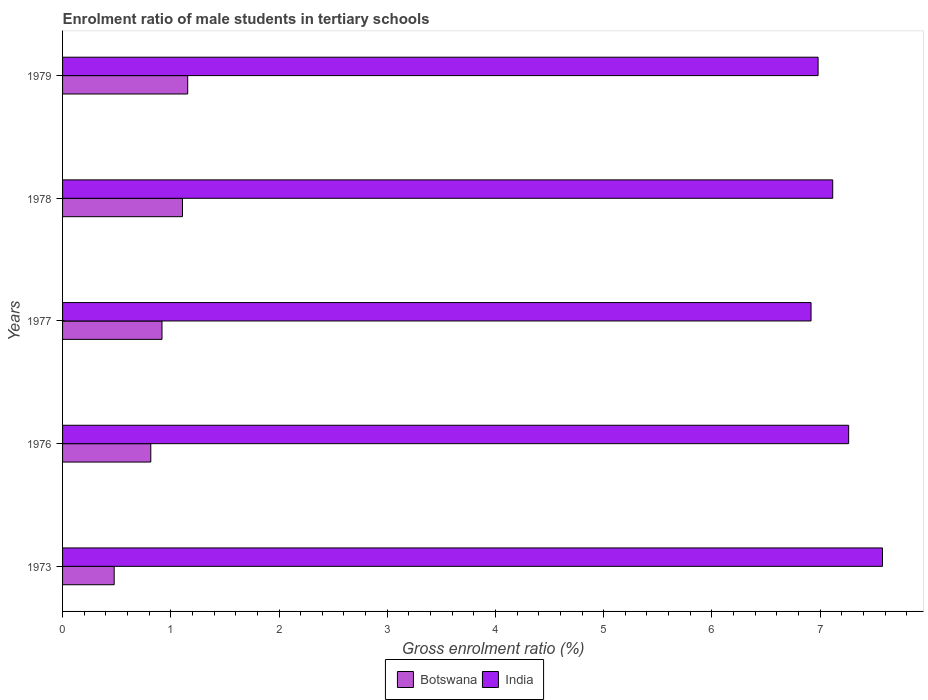Are the number of bars on each tick of the Y-axis equal?
Your response must be concise. Yes. How many bars are there on the 3rd tick from the bottom?
Give a very brief answer. 2. What is the label of the 4th group of bars from the top?
Make the answer very short. 1976. What is the enrolment ratio of male students in tertiary schools in India in 1976?
Provide a short and direct response. 7.26. Across all years, what is the maximum enrolment ratio of male students in tertiary schools in India?
Give a very brief answer. 7.58. Across all years, what is the minimum enrolment ratio of male students in tertiary schools in India?
Give a very brief answer. 6.92. What is the total enrolment ratio of male students in tertiary schools in Botswana in the graph?
Offer a terse response. 4.48. What is the difference between the enrolment ratio of male students in tertiary schools in Botswana in 1976 and that in 1978?
Your answer should be very brief. -0.29. What is the difference between the enrolment ratio of male students in tertiary schools in India in 1977 and the enrolment ratio of male students in tertiary schools in Botswana in 1973?
Provide a succinct answer. 6.44. What is the average enrolment ratio of male students in tertiary schools in India per year?
Make the answer very short. 7.17. In the year 1977, what is the difference between the enrolment ratio of male students in tertiary schools in Botswana and enrolment ratio of male students in tertiary schools in India?
Your answer should be very brief. -6. In how many years, is the enrolment ratio of male students in tertiary schools in India greater than 2.8 %?
Your response must be concise. 5. What is the ratio of the enrolment ratio of male students in tertiary schools in India in 1976 to that in 1979?
Make the answer very short. 1.04. Is the difference between the enrolment ratio of male students in tertiary schools in Botswana in 1978 and 1979 greater than the difference between the enrolment ratio of male students in tertiary schools in India in 1978 and 1979?
Your answer should be compact. No. What is the difference between the highest and the second highest enrolment ratio of male students in tertiary schools in Botswana?
Your answer should be very brief. 0.05. What is the difference between the highest and the lowest enrolment ratio of male students in tertiary schools in Botswana?
Your response must be concise. 0.68. In how many years, is the enrolment ratio of male students in tertiary schools in Botswana greater than the average enrolment ratio of male students in tertiary schools in Botswana taken over all years?
Give a very brief answer. 3. What does the 1st bar from the bottom in 1978 represents?
Your answer should be compact. Botswana. How many bars are there?
Your response must be concise. 10. How many years are there in the graph?
Ensure brevity in your answer.  5. What is the difference between two consecutive major ticks on the X-axis?
Provide a short and direct response. 1. Are the values on the major ticks of X-axis written in scientific E-notation?
Provide a short and direct response. No. Does the graph contain grids?
Give a very brief answer. No. How many legend labels are there?
Provide a succinct answer. 2. How are the legend labels stacked?
Provide a succinct answer. Horizontal. What is the title of the graph?
Keep it short and to the point. Enrolment ratio of male students in tertiary schools. What is the Gross enrolment ratio (%) of Botswana in 1973?
Keep it short and to the point. 0.48. What is the Gross enrolment ratio (%) of India in 1973?
Your answer should be compact. 7.58. What is the Gross enrolment ratio (%) in Botswana in 1976?
Provide a succinct answer. 0.82. What is the Gross enrolment ratio (%) in India in 1976?
Your answer should be compact. 7.26. What is the Gross enrolment ratio (%) of Botswana in 1977?
Your response must be concise. 0.92. What is the Gross enrolment ratio (%) of India in 1977?
Offer a terse response. 6.92. What is the Gross enrolment ratio (%) of Botswana in 1978?
Offer a very short reply. 1.11. What is the Gross enrolment ratio (%) of India in 1978?
Your answer should be very brief. 7.12. What is the Gross enrolment ratio (%) of Botswana in 1979?
Your response must be concise. 1.16. What is the Gross enrolment ratio (%) of India in 1979?
Make the answer very short. 6.98. Across all years, what is the maximum Gross enrolment ratio (%) in Botswana?
Your answer should be compact. 1.16. Across all years, what is the maximum Gross enrolment ratio (%) in India?
Provide a succinct answer. 7.58. Across all years, what is the minimum Gross enrolment ratio (%) in Botswana?
Give a very brief answer. 0.48. Across all years, what is the minimum Gross enrolment ratio (%) of India?
Keep it short and to the point. 6.92. What is the total Gross enrolment ratio (%) of Botswana in the graph?
Provide a short and direct response. 4.48. What is the total Gross enrolment ratio (%) of India in the graph?
Provide a succinct answer. 35.85. What is the difference between the Gross enrolment ratio (%) in Botswana in 1973 and that in 1976?
Keep it short and to the point. -0.34. What is the difference between the Gross enrolment ratio (%) of India in 1973 and that in 1976?
Offer a very short reply. 0.31. What is the difference between the Gross enrolment ratio (%) in Botswana in 1973 and that in 1977?
Ensure brevity in your answer.  -0.44. What is the difference between the Gross enrolment ratio (%) of India in 1973 and that in 1977?
Make the answer very short. 0.66. What is the difference between the Gross enrolment ratio (%) in Botswana in 1973 and that in 1978?
Offer a very short reply. -0.63. What is the difference between the Gross enrolment ratio (%) of India in 1973 and that in 1978?
Give a very brief answer. 0.46. What is the difference between the Gross enrolment ratio (%) in Botswana in 1973 and that in 1979?
Keep it short and to the point. -0.68. What is the difference between the Gross enrolment ratio (%) of India in 1973 and that in 1979?
Ensure brevity in your answer.  0.59. What is the difference between the Gross enrolment ratio (%) in Botswana in 1976 and that in 1977?
Offer a terse response. -0.1. What is the difference between the Gross enrolment ratio (%) in India in 1976 and that in 1977?
Offer a terse response. 0.35. What is the difference between the Gross enrolment ratio (%) of Botswana in 1976 and that in 1978?
Your response must be concise. -0.29. What is the difference between the Gross enrolment ratio (%) in India in 1976 and that in 1978?
Ensure brevity in your answer.  0.15. What is the difference between the Gross enrolment ratio (%) in Botswana in 1976 and that in 1979?
Offer a terse response. -0.34. What is the difference between the Gross enrolment ratio (%) in India in 1976 and that in 1979?
Your response must be concise. 0.28. What is the difference between the Gross enrolment ratio (%) in Botswana in 1977 and that in 1978?
Keep it short and to the point. -0.19. What is the difference between the Gross enrolment ratio (%) of India in 1977 and that in 1978?
Offer a very short reply. -0.2. What is the difference between the Gross enrolment ratio (%) in Botswana in 1977 and that in 1979?
Offer a very short reply. -0.24. What is the difference between the Gross enrolment ratio (%) in India in 1977 and that in 1979?
Your response must be concise. -0.07. What is the difference between the Gross enrolment ratio (%) in Botswana in 1978 and that in 1979?
Provide a succinct answer. -0.05. What is the difference between the Gross enrolment ratio (%) in India in 1978 and that in 1979?
Your answer should be compact. 0.14. What is the difference between the Gross enrolment ratio (%) of Botswana in 1973 and the Gross enrolment ratio (%) of India in 1976?
Offer a terse response. -6.79. What is the difference between the Gross enrolment ratio (%) in Botswana in 1973 and the Gross enrolment ratio (%) in India in 1977?
Your response must be concise. -6.44. What is the difference between the Gross enrolment ratio (%) in Botswana in 1973 and the Gross enrolment ratio (%) in India in 1978?
Offer a very short reply. -6.64. What is the difference between the Gross enrolment ratio (%) in Botswana in 1973 and the Gross enrolment ratio (%) in India in 1979?
Keep it short and to the point. -6.5. What is the difference between the Gross enrolment ratio (%) of Botswana in 1976 and the Gross enrolment ratio (%) of India in 1977?
Offer a terse response. -6.1. What is the difference between the Gross enrolment ratio (%) of Botswana in 1976 and the Gross enrolment ratio (%) of India in 1978?
Your answer should be very brief. -6.3. What is the difference between the Gross enrolment ratio (%) of Botswana in 1976 and the Gross enrolment ratio (%) of India in 1979?
Offer a very short reply. -6.17. What is the difference between the Gross enrolment ratio (%) of Botswana in 1977 and the Gross enrolment ratio (%) of India in 1978?
Offer a very short reply. -6.2. What is the difference between the Gross enrolment ratio (%) in Botswana in 1977 and the Gross enrolment ratio (%) in India in 1979?
Your answer should be compact. -6.06. What is the difference between the Gross enrolment ratio (%) in Botswana in 1978 and the Gross enrolment ratio (%) in India in 1979?
Offer a very short reply. -5.87. What is the average Gross enrolment ratio (%) in Botswana per year?
Provide a short and direct response. 0.9. What is the average Gross enrolment ratio (%) in India per year?
Keep it short and to the point. 7.17. In the year 1973, what is the difference between the Gross enrolment ratio (%) of Botswana and Gross enrolment ratio (%) of India?
Provide a succinct answer. -7.1. In the year 1976, what is the difference between the Gross enrolment ratio (%) in Botswana and Gross enrolment ratio (%) in India?
Keep it short and to the point. -6.45. In the year 1977, what is the difference between the Gross enrolment ratio (%) of Botswana and Gross enrolment ratio (%) of India?
Make the answer very short. -6. In the year 1978, what is the difference between the Gross enrolment ratio (%) in Botswana and Gross enrolment ratio (%) in India?
Offer a very short reply. -6.01. In the year 1979, what is the difference between the Gross enrolment ratio (%) in Botswana and Gross enrolment ratio (%) in India?
Make the answer very short. -5.83. What is the ratio of the Gross enrolment ratio (%) in Botswana in 1973 to that in 1976?
Make the answer very short. 0.59. What is the ratio of the Gross enrolment ratio (%) in India in 1973 to that in 1976?
Your response must be concise. 1.04. What is the ratio of the Gross enrolment ratio (%) of Botswana in 1973 to that in 1977?
Your answer should be very brief. 0.52. What is the ratio of the Gross enrolment ratio (%) in India in 1973 to that in 1977?
Keep it short and to the point. 1.1. What is the ratio of the Gross enrolment ratio (%) of Botswana in 1973 to that in 1978?
Provide a succinct answer. 0.43. What is the ratio of the Gross enrolment ratio (%) of India in 1973 to that in 1978?
Ensure brevity in your answer.  1.06. What is the ratio of the Gross enrolment ratio (%) in Botswana in 1973 to that in 1979?
Offer a very short reply. 0.41. What is the ratio of the Gross enrolment ratio (%) of India in 1973 to that in 1979?
Provide a succinct answer. 1.09. What is the ratio of the Gross enrolment ratio (%) of Botswana in 1976 to that in 1977?
Keep it short and to the point. 0.89. What is the ratio of the Gross enrolment ratio (%) of India in 1976 to that in 1977?
Provide a short and direct response. 1.05. What is the ratio of the Gross enrolment ratio (%) in Botswana in 1976 to that in 1978?
Provide a short and direct response. 0.74. What is the ratio of the Gross enrolment ratio (%) in India in 1976 to that in 1978?
Make the answer very short. 1.02. What is the ratio of the Gross enrolment ratio (%) of Botswana in 1976 to that in 1979?
Your response must be concise. 0.71. What is the ratio of the Gross enrolment ratio (%) in India in 1976 to that in 1979?
Your response must be concise. 1.04. What is the ratio of the Gross enrolment ratio (%) in Botswana in 1977 to that in 1978?
Provide a short and direct response. 0.83. What is the ratio of the Gross enrolment ratio (%) of India in 1977 to that in 1978?
Give a very brief answer. 0.97. What is the ratio of the Gross enrolment ratio (%) in Botswana in 1977 to that in 1979?
Your response must be concise. 0.79. What is the ratio of the Gross enrolment ratio (%) of Botswana in 1978 to that in 1979?
Keep it short and to the point. 0.96. What is the ratio of the Gross enrolment ratio (%) in India in 1978 to that in 1979?
Offer a terse response. 1.02. What is the difference between the highest and the second highest Gross enrolment ratio (%) in Botswana?
Your answer should be compact. 0.05. What is the difference between the highest and the second highest Gross enrolment ratio (%) of India?
Your answer should be compact. 0.31. What is the difference between the highest and the lowest Gross enrolment ratio (%) of Botswana?
Offer a terse response. 0.68. What is the difference between the highest and the lowest Gross enrolment ratio (%) in India?
Ensure brevity in your answer.  0.66. 